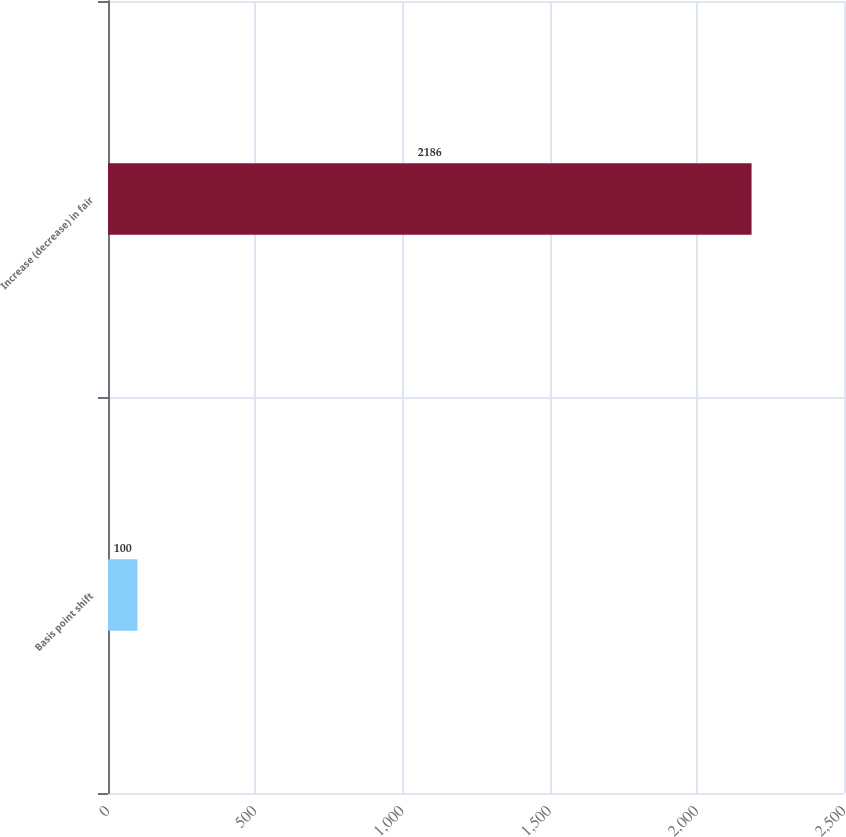Convert chart to OTSL. <chart><loc_0><loc_0><loc_500><loc_500><bar_chart><fcel>Basis point shift<fcel>Increase (decrease) in fair<nl><fcel>100<fcel>2186<nl></chart> 